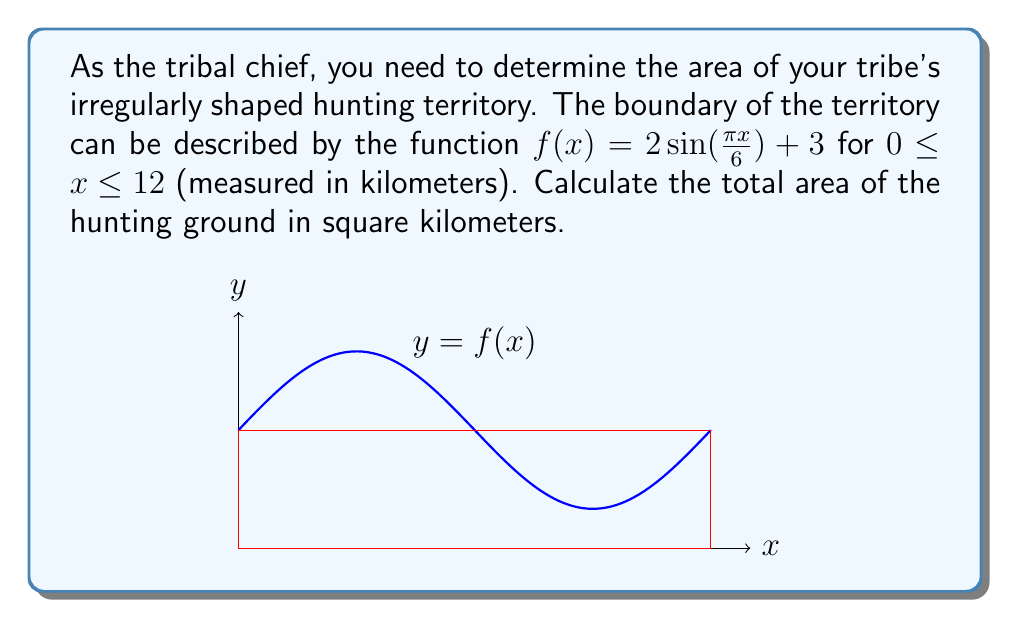Could you help me with this problem? To find the area of the irregularly shaped hunting territory, we need to use definite integration. The steps are as follows:

1) The area under a curve $y = f(x)$ from $a$ to $b$ is given by the definite integral:

   $$A = \int_{a}^{b} f(x) dx$$

2) In this case, $f(x) = 2\sin(\frac{\pi x}{6}) + 3$, $a = 0$, and $b = 12$. So we have:

   $$A = \int_{0}^{12} (2\sin(\frac{\pi x}{6}) + 3) dx$$

3) We can split this integral:

   $$A = \int_{0}^{12} 2\sin(\frac{\pi x}{6}) dx + \int_{0}^{12} 3 dx$$

4) For the first integral, we use the substitution $u = \frac{\pi x}{6}$, so $du = \frac{\pi}{6} dx$ or $dx = \frac{6}{\pi} du$:

   $$\int_{0}^{12} 2\sin(\frac{\pi x}{6}) dx = \frac{12}{\pi} \int_{0}^{2\pi} \sin(u) du = \frac{12}{\pi} [-\cos(u)]_{0}^{2\pi} = \frac{12}{\pi} [(-\cos(2\pi)) - (-\cos(0))] = 0$$

5) The second integral is straightforward:

   $$\int_{0}^{12} 3 dx = 3x \big|_{0}^{12} = 36$$

6) Adding the results from steps 4 and 5:

   $$A = 0 + 36 = 36$$

Therefore, the total area of the hunting ground is 36 square kilometers.
Answer: 36 km² 